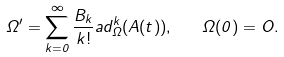Convert formula to latex. <formula><loc_0><loc_0><loc_500><loc_500>\Omega ^ { \prime } = \sum _ { k = 0 } ^ { \infty } \frac { B _ { k } } { k ! } a d _ { \Omega } ^ { k } ( A ( t ) ) , \quad \Omega ( 0 ) = O .</formula> 